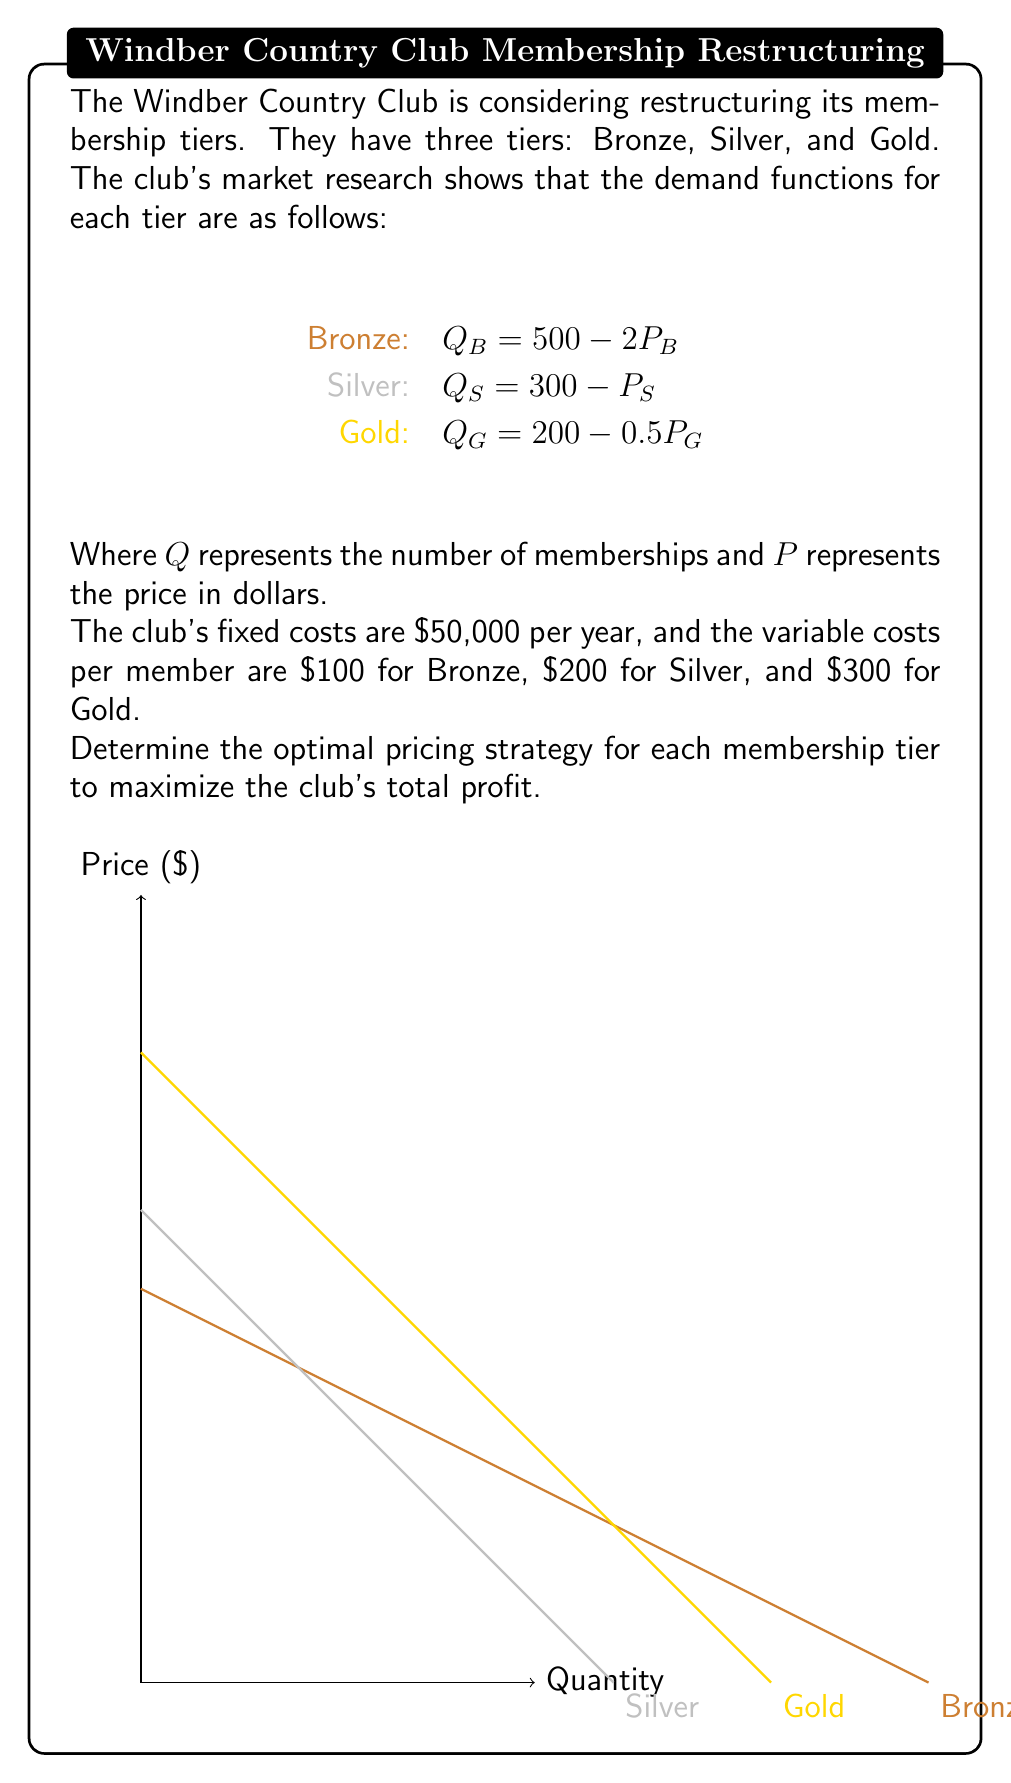Teach me how to tackle this problem. Let's approach this step-by-step:

1) First, we need to formulate the profit function for each tier. The general form is:
   Profit = Revenue - Total Cost
   where Revenue = Price × Quantity and Total Cost = Fixed Cost + Variable Cost × Quantity

2) For each tier:
   Bronze: $\pi_B = P_B Q_B - (100Q_B + \frac{50000}{3})$
   Silver: $\pi_S = P_S Q_S - (200Q_S + \frac{50000}{3})$
   Gold: $\pi_G = P_G Q_G - (300Q_G + \frac{50000}{3})$

3) Substitute the demand functions:
   Bronze: $\pi_B = P_B (500 - 2P_B) - (100(500 - 2P_B) + \frac{50000}{3})$
   Silver: $\pi_S = P_S (300 - P_S) - (200(300 - P_S) + \frac{50000}{3})$
   Gold: $\pi_G = P_G (200 - 0.5P_G) - (300(200 - 0.5P_G) + \frac{50000}{3})$

4) To maximize profit, we differentiate each function with respect to its price and set it to zero:

   Bronze: $\frac{d\pi_B}{dP_B} = 500 - 4P_B + 200 = 0$
           $700 - 4P_B = 0$
           $P_B = 175$

   Silver: $\frac{d\pi_S}{dP_S} = 300 - 2P_S + 200 = 0$
           $500 - 2P_S = 0$
           $P_S = 250$

   Gold: $\frac{d\pi_G}{dP_G} = 200 - P_G + 150 = 0$
         $350 - P_G = 0$
         $P_G = 350$

5) Now we can calculate the quantities for each tier:
   Bronze: $Q_B = 500 - 2(175) = 150$
   Silver: $Q_S = 300 - 250 = 50$
   Gold: $Q_G = 200 - 0.5(350) = 25$

6) Finally, we can calculate the profit for each tier:
   Bronze: $\pi_B = 175 \times 150 - (100 \times 150 + \frac{50000}{3}) = 8,333.33$
   Silver: $\pi_S = 250 \times 50 - (200 \times 50 + \frac{50000}{3}) = 8,333.33$
   Gold: $\pi_G = 350 \times 25 - (300 \times 25 + \frac{50000}{3}) = 8,333.33$

   Total Profit = $24,999.99$
Answer: Bronze: $\$175$, Silver: $\$250$, Gold: $\$350$ 